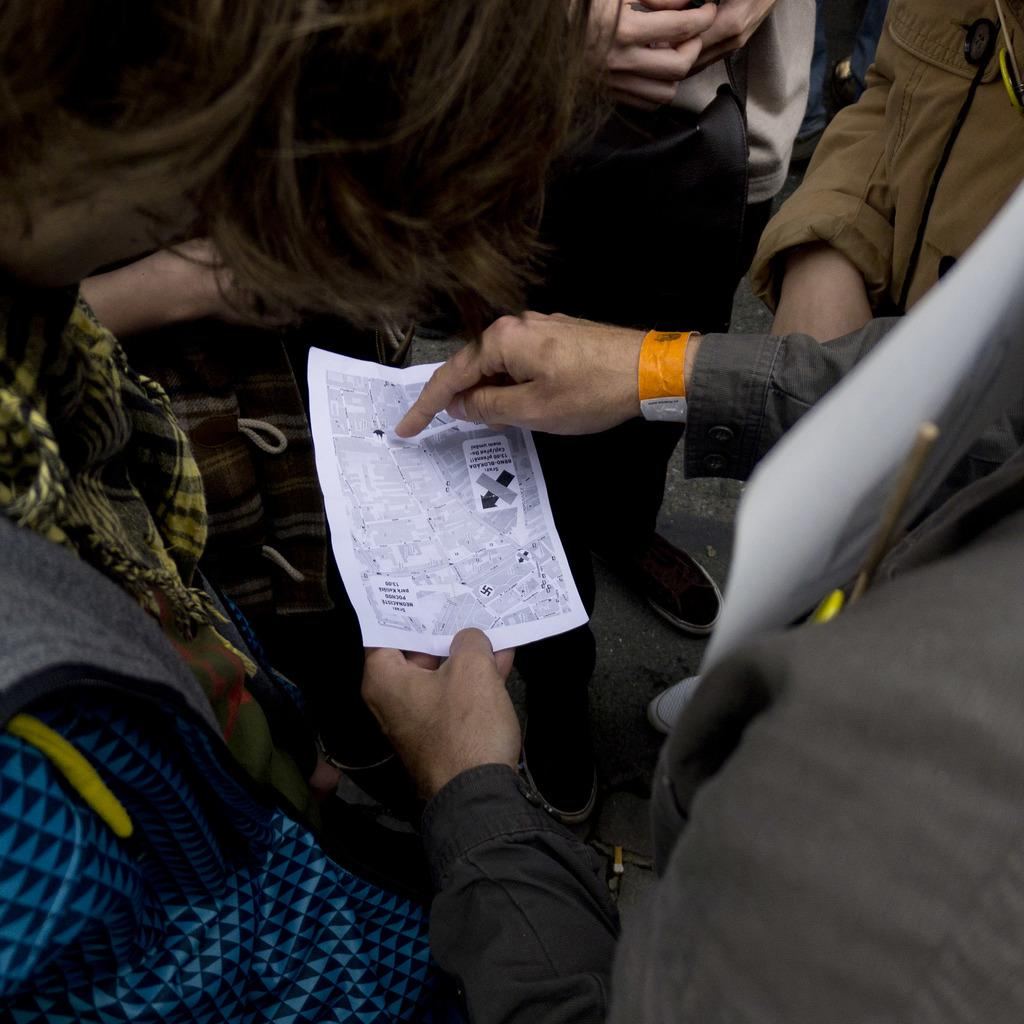How many people are in the image? There are few persons in the image. What is one of the persons doing with his hands? One of the persons is holding a paper with his hands. What is the amount of quicksand present in the image? There is no quicksand present in the image. Is the seashore visible in the image? The provided facts do not mention the seashore, so we cannot determine if it is visible in the image. 